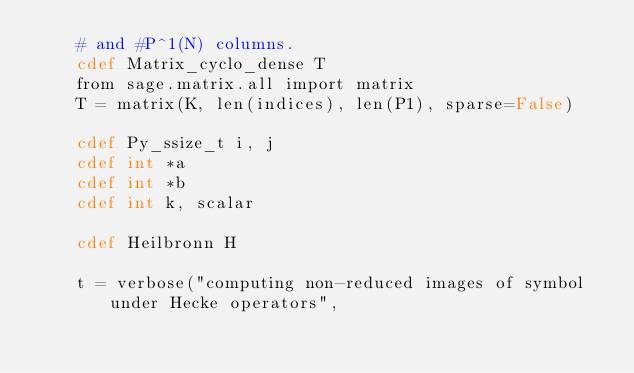<code> <loc_0><loc_0><loc_500><loc_500><_Cython_>    # and #P^1(N) columns.
    cdef Matrix_cyclo_dense T
    from sage.matrix.all import matrix
    T = matrix(K, len(indices), len(P1), sparse=False)

    cdef Py_ssize_t i, j
    cdef int *a
    cdef int *b
    cdef int k, scalar

    cdef Heilbronn H

    t = verbose("computing non-reduced images of symbol under Hecke operators",</code> 